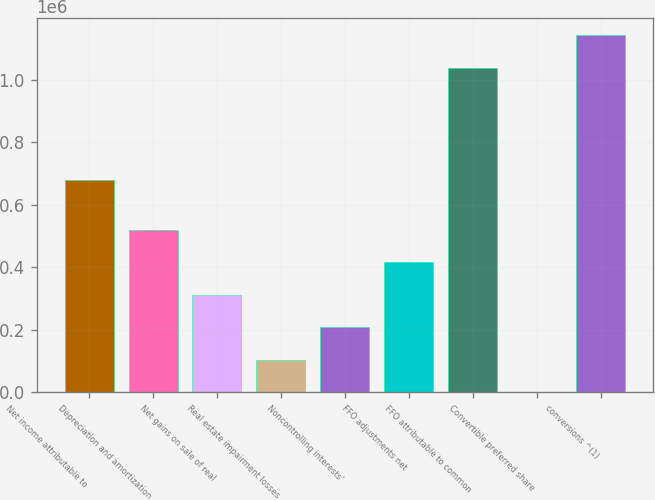Convert chart. <chart><loc_0><loc_0><loc_500><loc_500><bar_chart><fcel>Net income attributable to<fcel>Depreciation and amortization<fcel>Net gains on sale of real<fcel>Real estate impairment losses<fcel>Noncontrolling interests'<fcel>FFO adjustments net<fcel>FFO attributable to common<fcel>Convertible preferred share<fcel>conversions ^(1)<nl><fcel>679856<fcel>519564<fcel>311775<fcel>103986<fcel>207881<fcel>415669<fcel>1.03894e+06<fcel>92<fcel>1.14284e+06<nl></chart> 